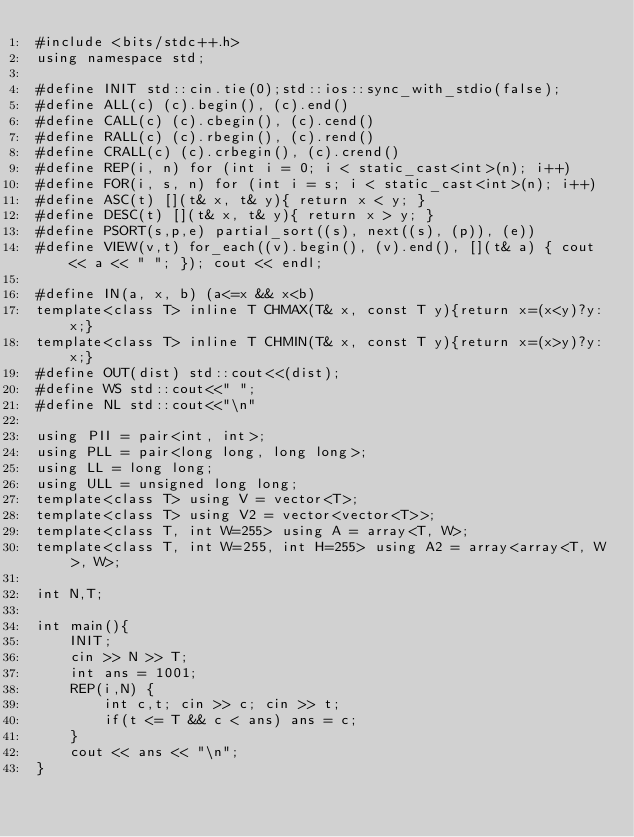Convert code to text. <code><loc_0><loc_0><loc_500><loc_500><_C++_>#include <bits/stdc++.h>
using namespace std;

#define INIT std::cin.tie(0);std::ios::sync_with_stdio(false);
#define ALL(c) (c).begin(), (c).end()
#define CALL(c) (c).cbegin(), (c).cend()
#define RALL(c) (c).rbegin(), (c).rend()
#define CRALL(c) (c).crbegin(), (c).crend()
#define REP(i, n) for (int i = 0; i < static_cast<int>(n); i++)
#define FOR(i, s, n) for (int i = s; i < static_cast<int>(n); i++)
#define ASC(t) [](t& x, t& y){ return x < y; }
#define DESC(t) [](t& x, t& y){ return x > y; }
#define PSORT(s,p,e) partial_sort((s), next((s), (p)), (e))
#define VIEW(v,t) for_each((v).begin(), (v).end(), [](t& a) { cout << a << " "; }); cout << endl;

#define IN(a, x, b) (a<=x && x<b)
template<class T> inline T CHMAX(T& x, const T y){return x=(x<y)?y:x;}
template<class T> inline T CHMIN(T& x, const T y){return x=(x>y)?y:x;}
#define OUT(dist) std::cout<<(dist);
#define WS std::cout<<" ";
#define NL std::cout<<"\n"

using PII = pair<int, int>;
using PLL = pair<long long, long long>;
using LL = long long;
using ULL = unsigned long long;
template<class T> using V = vector<T>;
template<class T> using V2 = vector<vector<T>>;
template<class T, int W=255> using A = array<T, W>;
template<class T, int W=255, int H=255> using A2 = array<array<T, W>, W>;

int N,T;

int main(){
    INIT;
    cin >> N >> T;
    int ans = 1001;
    REP(i,N) {
        int c,t; cin >> c; cin >> t;
        if(t <= T && c < ans) ans = c;
    }
    cout << ans << "\n";
}</code> 